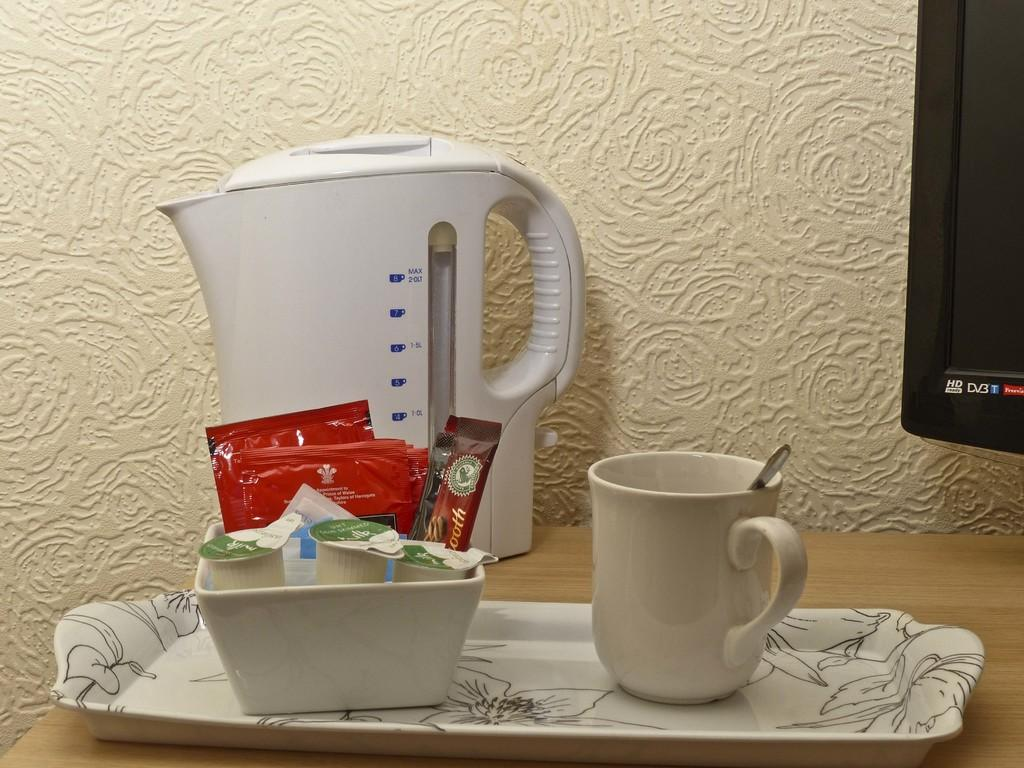Provide a one-sentence caption for the provided image. An HD TV sits to the side of a breakfast array. 